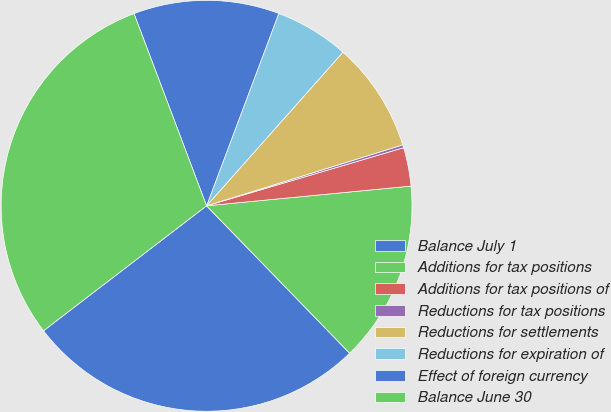<chart> <loc_0><loc_0><loc_500><loc_500><pie_chart><fcel>Balance July 1<fcel>Additions for tax positions<fcel>Additions for tax positions of<fcel>Reductions for tax positions<fcel>Reductions for settlements<fcel>Reductions for expiration of<fcel>Effect of foreign currency<fcel>Balance June 30<nl><fcel>26.85%<fcel>14.27%<fcel>3.03%<fcel>0.23%<fcel>8.65%<fcel>5.84%<fcel>11.46%<fcel>29.66%<nl></chart> 